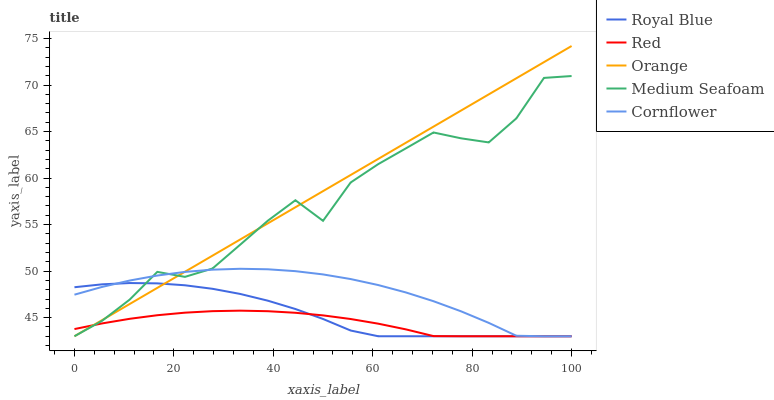Does Red have the minimum area under the curve?
Answer yes or no. Yes. Does Orange have the maximum area under the curve?
Answer yes or no. Yes. Does Royal Blue have the minimum area under the curve?
Answer yes or no. No. Does Royal Blue have the maximum area under the curve?
Answer yes or no. No. Is Orange the smoothest?
Answer yes or no. Yes. Is Medium Seafoam the roughest?
Answer yes or no. Yes. Is Royal Blue the smoothest?
Answer yes or no. No. Is Royal Blue the roughest?
Answer yes or no. No. Does Orange have the lowest value?
Answer yes or no. Yes. Does Orange have the highest value?
Answer yes or no. Yes. Does Royal Blue have the highest value?
Answer yes or no. No. Does Cornflower intersect Medium Seafoam?
Answer yes or no. Yes. Is Cornflower less than Medium Seafoam?
Answer yes or no. No. Is Cornflower greater than Medium Seafoam?
Answer yes or no. No. 